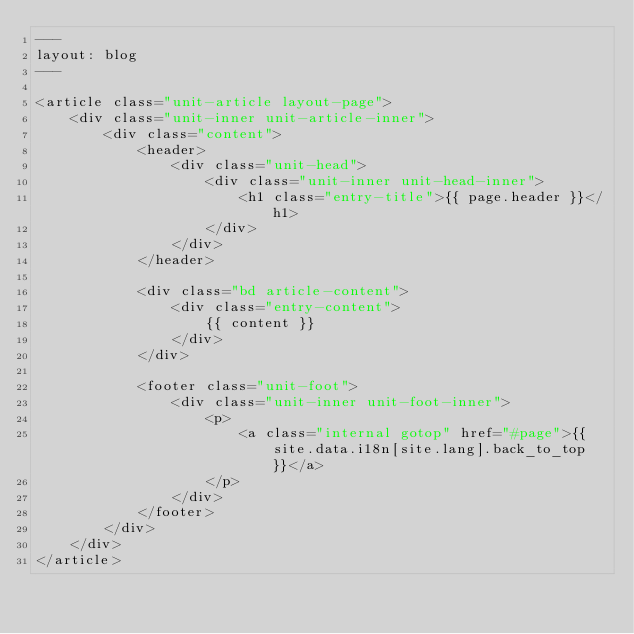Convert code to text. <code><loc_0><loc_0><loc_500><loc_500><_HTML_>---
layout: blog
---

<article class="unit-article layout-page">
    <div class="unit-inner unit-article-inner">
        <div class="content">
            <header>
                <div class="unit-head">
                    <div class="unit-inner unit-head-inner">
                        <h1 class="entry-title">{{ page.header }}</h1>
                    </div>
                </div>
            </header>

            <div class="bd article-content">
                <div class="entry-content">
                    {{ content }}
                </div>
            </div>

            <footer class="unit-foot">
                <div class="unit-inner unit-foot-inner">
                    <p>
                        <a class="internal gotop" href="#page">{{ site.data.i18n[site.lang].back_to_top }}</a>
                    </p>
                </div>
            </footer>
        </div>
    </div>
</article></code> 